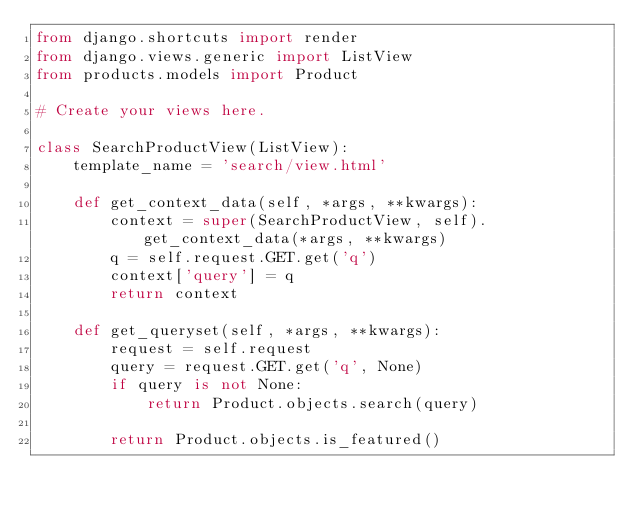Convert code to text. <code><loc_0><loc_0><loc_500><loc_500><_Python_>from django.shortcuts import render
from django.views.generic import ListView
from products.models import Product

# Create your views here.

class SearchProductView(ListView):
    template_name = 'search/view.html'

    def get_context_data(self, *args, **kwargs):
        context = super(SearchProductView, self).get_context_data(*args, **kwargs)
        q = self.request.GET.get('q')
        context['query'] = q
        return context

    def get_queryset(self, *args, **kwargs):
        request = self.request
        query = request.GET.get('q', None)
        if query is not None:
            return Product.objects.search(query)

        return Product.objects.is_featured()</code> 